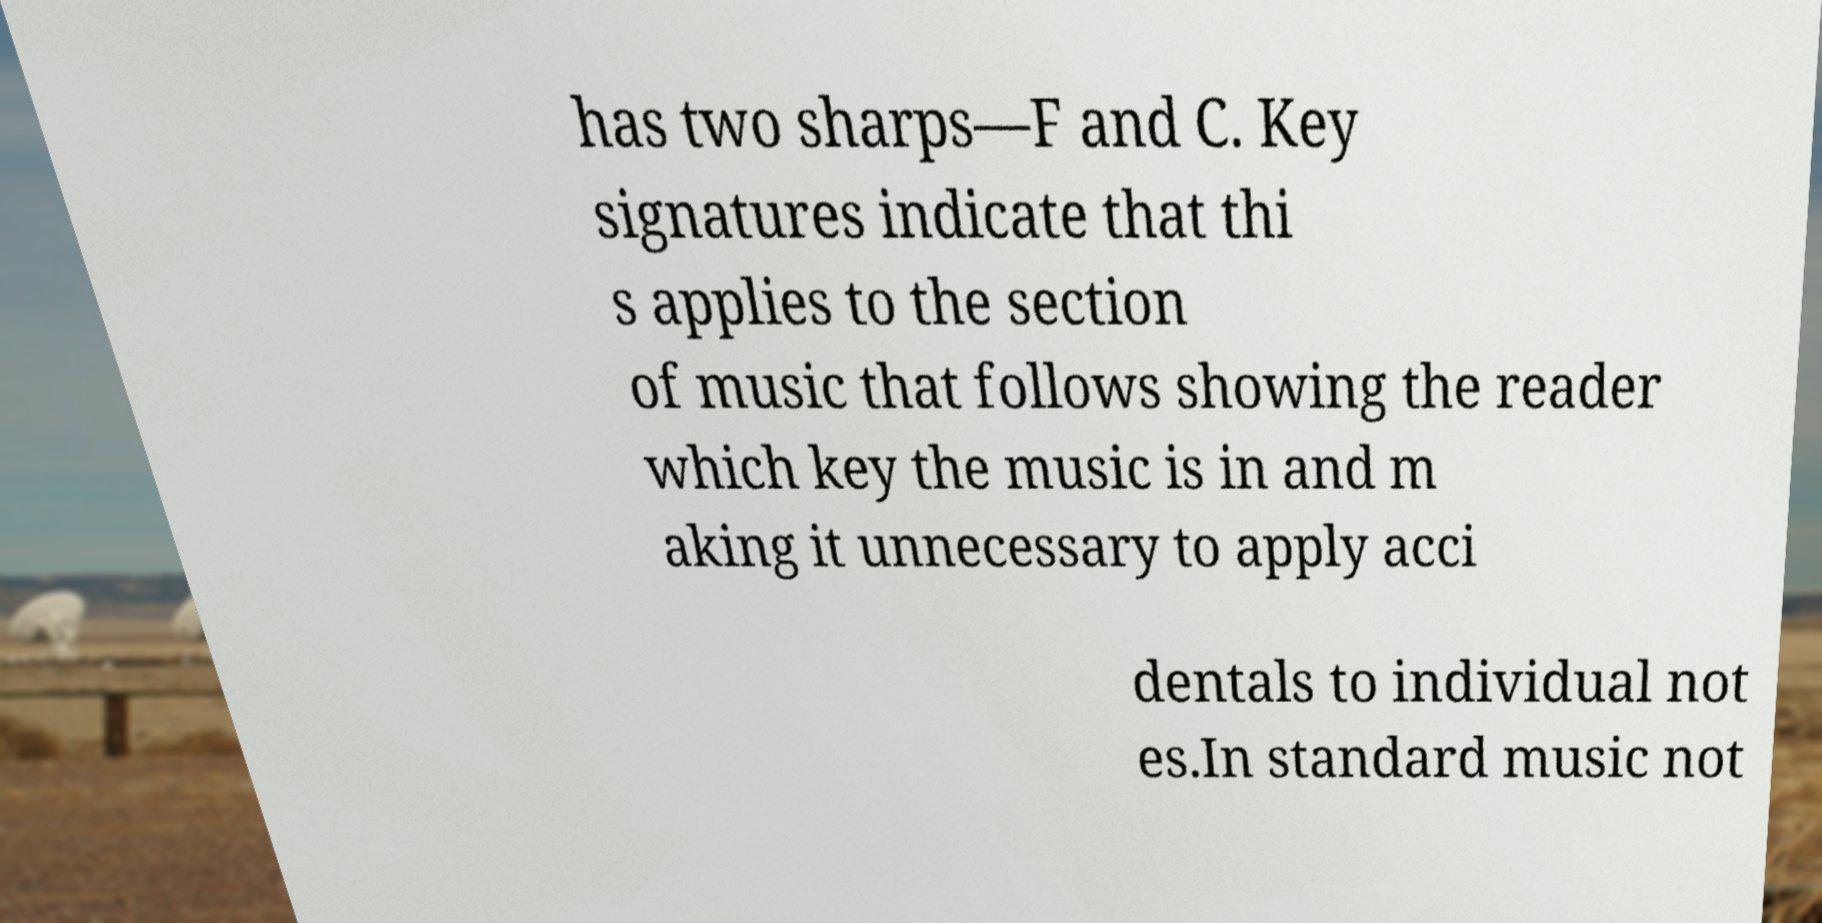What messages or text are displayed in this image? I need them in a readable, typed format. has two sharps—F and C. Key signatures indicate that thi s applies to the section of music that follows showing the reader which key the music is in and m aking it unnecessary to apply acci dentals to individual not es.In standard music not 